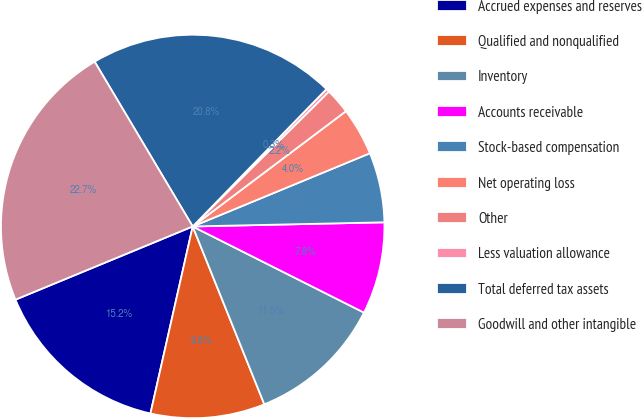Convert chart. <chart><loc_0><loc_0><loc_500><loc_500><pie_chart><fcel>Accrued expenses and reserves<fcel>Qualified and nonqualified<fcel>Inventory<fcel>Accounts receivable<fcel>Stock-based compensation<fcel>Net operating loss<fcel>Other<fcel>Less valuation allowance<fcel>Total deferred tax assets<fcel>Goodwill and other intangible<nl><fcel>15.23%<fcel>9.63%<fcel>11.49%<fcel>7.76%<fcel>5.89%<fcel>4.03%<fcel>2.16%<fcel>0.29%<fcel>20.83%<fcel>22.69%<nl></chart> 